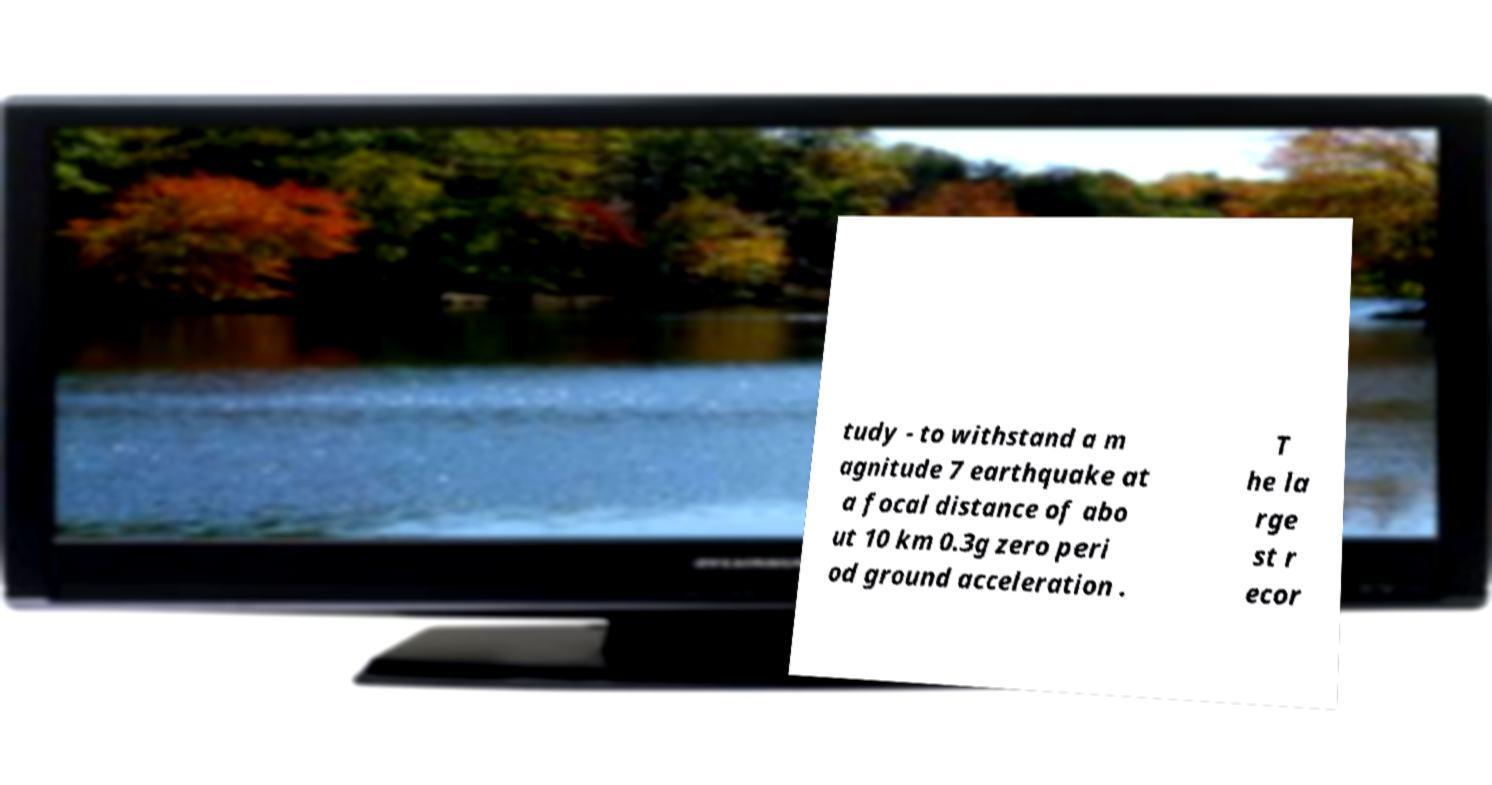Please read and relay the text visible in this image. What does it say? tudy - to withstand a m agnitude 7 earthquake at a focal distance of abo ut 10 km 0.3g zero peri od ground acceleration . T he la rge st r ecor 